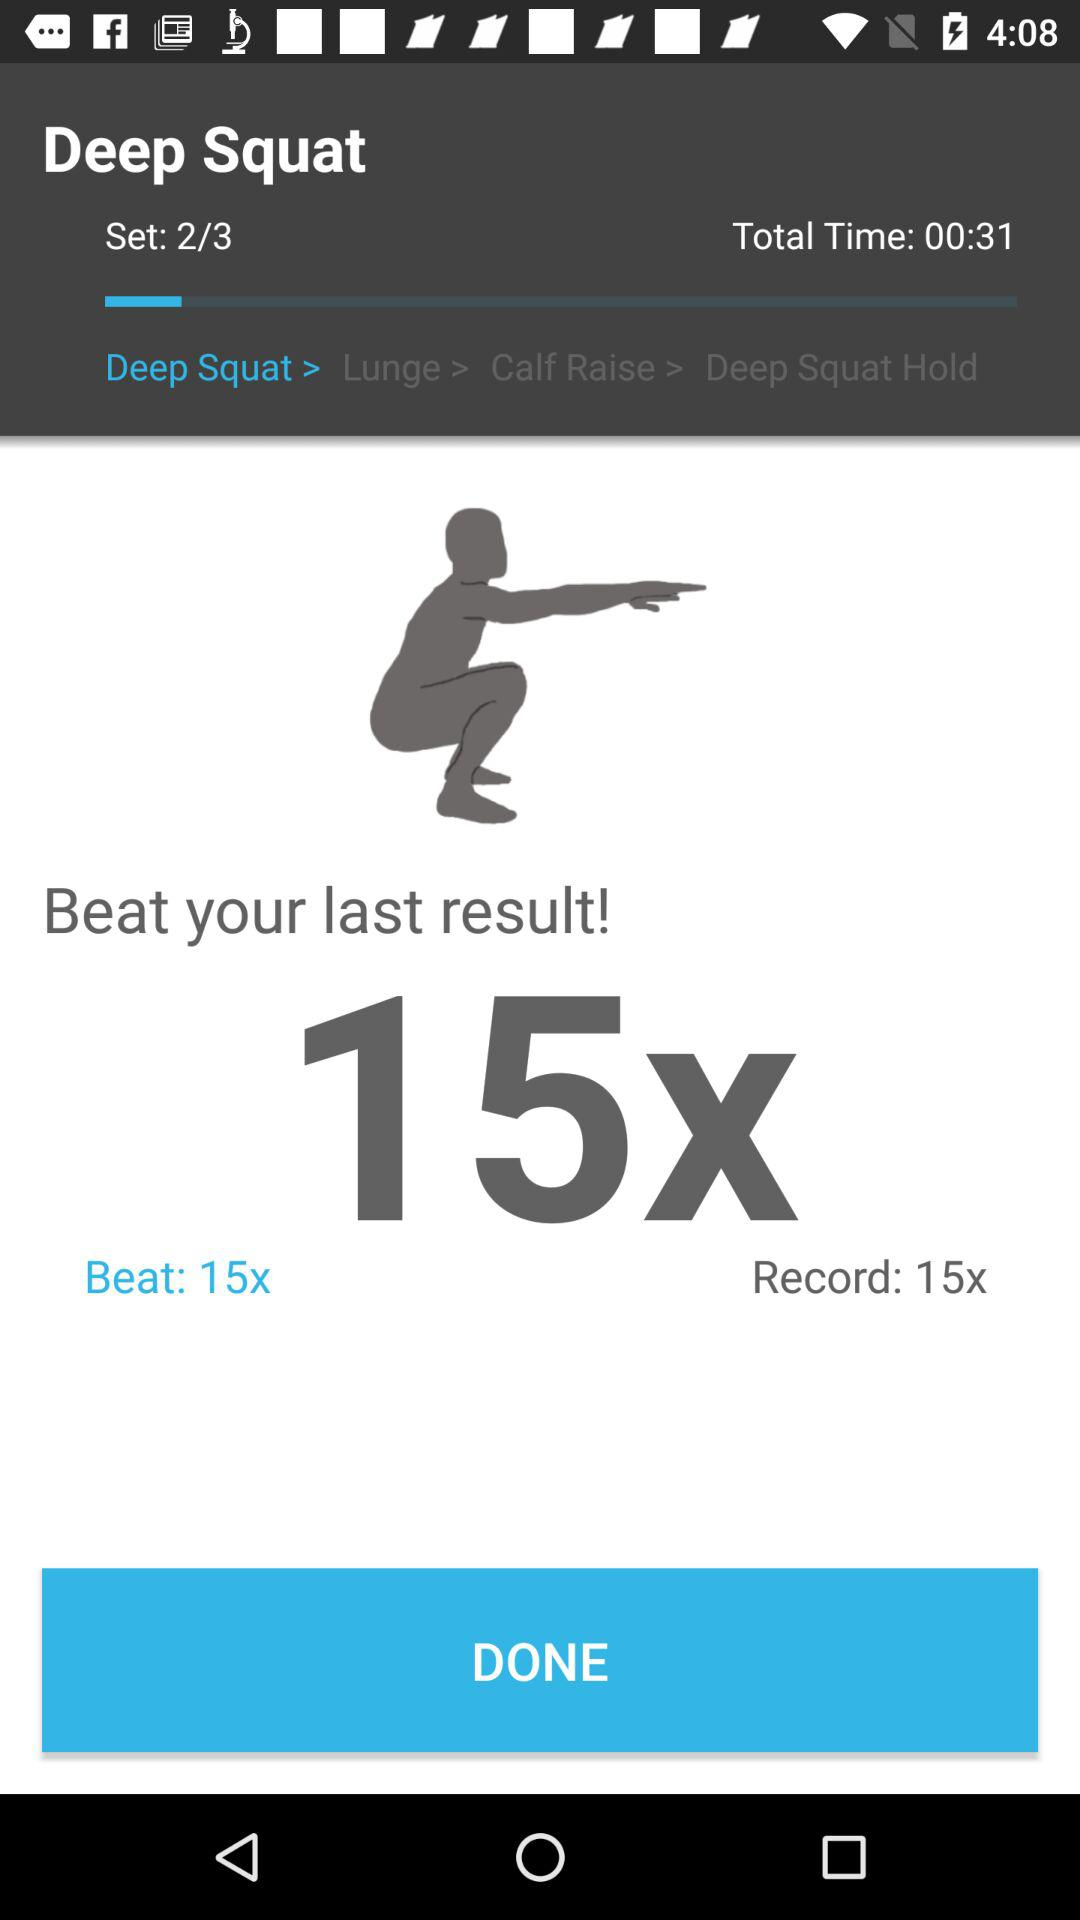What is the total time? The total time is 31 seconds. 